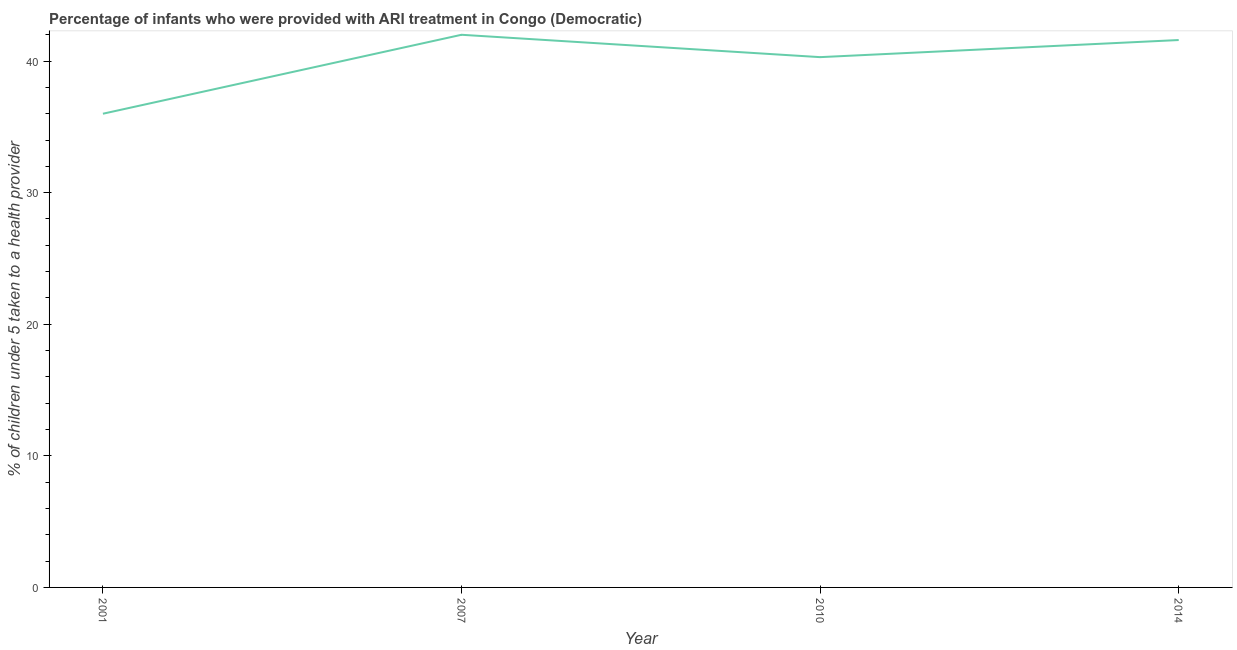What is the percentage of children who were provided with ari treatment in 2014?
Your response must be concise. 41.6. In which year was the percentage of children who were provided with ari treatment minimum?
Your response must be concise. 2001. What is the sum of the percentage of children who were provided with ari treatment?
Give a very brief answer. 159.9. What is the difference between the percentage of children who were provided with ari treatment in 2001 and 2010?
Provide a short and direct response. -4.3. What is the average percentage of children who were provided with ari treatment per year?
Make the answer very short. 39.98. What is the median percentage of children who were provided with ari treatment?
Your answer should be very brief. 40.95. What is the ratio of the percentage of children who were provided with ari treatment in 2007 to that in 2010?
Offer a very short reply. 1.04. Is the difference between the percentage of children who were provided with ari treatment in 2001 and 2010 greater than the difference between any two years?
Ensure brevity in your answer.  No. What is the difference between the highest and the second highest percentage of children who were provided with ari treatment?
Your answer should be compact. 0.4. Is the sum of the percentage of children who were provided with ari treatment in 2007 and 2014 greater than the maximum percentage of children who were provided with ari treatment across all years?
Make the answer very short. Yes. Does the percentage of children who were provided with ari treatment monotonically increase over the years?
Provide a short and direct response. No. How many years are there in the graph?
Make the answer very short. 4. Does the graph contain any zero values?
Provide a succinct answer. No. Does the graph contain grids?
Ensure brevity in your answer.  No. What is the title of the graph?
Offer a very short reply. Percentage of infants who were provided with ARI treatment in Congo (Democratic). What is the label or title of the X-axis?
Offer a terse response. Year. What is the label or title of the Y-axis?
Make the answer very short. % of children under 5 taken to a health provider. What is the % of children under 5 taken to a health provider of 2001?
Provide a succinct answer. 36. What is the % of children under 5 taken to a health provider of 2007?
Make the answer very short. 42. What is the % of children under 5 taken to a health provider of 2010?
Offer a very short reply. 40.3. What is the % of children under 5 taken to a health provider of 2014?
Provide a short and direct response. 41.6. What is the difference between the % of children under 5 taken to a health provider in 2001 and 2010?
Your answer should be compact. -4.3. What is the difference between the % of children under 5 taken to a health provider in 2007 and 2014?
Ensure brevity in your answer.  0.4. What is the difference between the % of children under 5 taken to a health provider in 2010 and 2014?
Your answer should be very brief. -1.3. What is the ratio of the % of children under 5 taken to a health provider in 2001 to that in 2007?
Keep it short and to the point. 0.86. What is the ratio of the % of children under 5 taken to a health provider in 2001 to that in 2010?
Provide a succinct answer. 0.89. What is the ratio of the % of children under 5 taken to a health provider in 2001 to that in 2014?
Keep it short and to the point. 0.86. What is the ratio of the % of children under 5 taken to a health provider in 2007 to that in 2010?
Offer a terse response. 1.04. What is the ratio of the % of children under 5 taken to a health provider in 2007 to that in 2014?
Make the answer very short. 1.01. What is the ratio of the % of children under 5 taken to a health provider in 2010 to that in 2014?
Offer a very short reply. 0.97. 